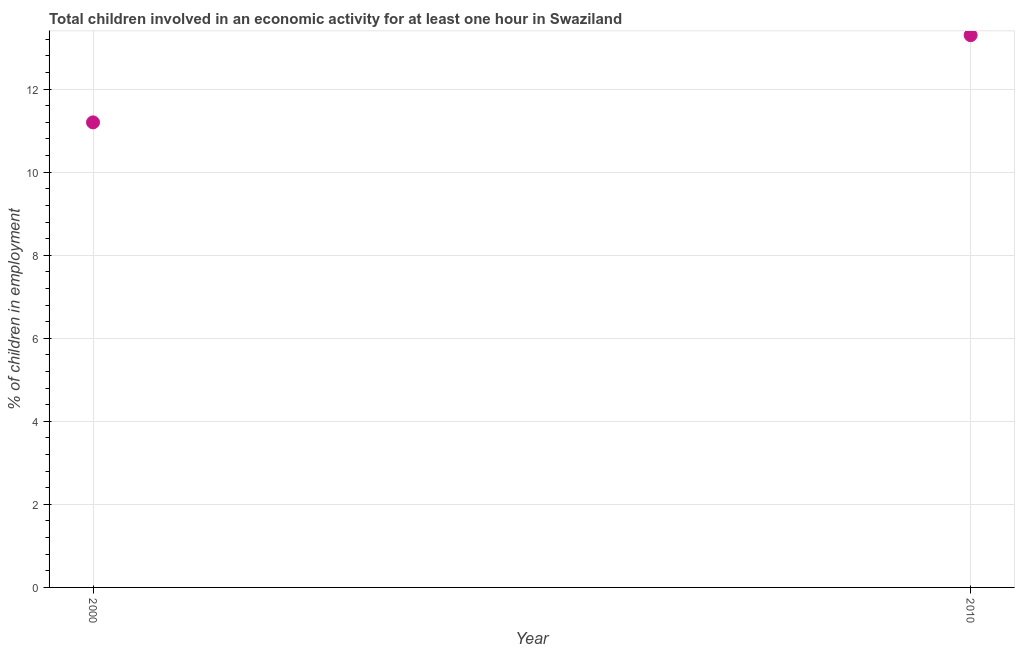Across all years, what is the maximum percentage of children in employment?
Your answer should be compact. 13.3. In which year was the percentage of children in employment maximum?
Provide a short and direct response. 2010. What is the difference between the percentage of children in employment in 2000 and 2010?
Ensure brevity in your answer.  -2.1. What is the average percentage of children in employment per year?
Provide a succinct answer. 12.25. What is the median percentage of children in employment?
Ensure brevity in your answer.  12.25. Do a majority of the years between 2000 and 2010 (inclusive) have percentage of children in employment greater than 3.6 %?
Make the answer very short. Yes. What is the ratio of the percentage of children in employment in 2000 to that in 2010?
Give a very brief answer. 0.84. Is the percentage of children in employment in 2000 less than that in 2010?
Your response must be concise. Yes. Does the percentage of children in employment monotonically increase over the years?
Your answer should be compact. Yes. How many dotlines are there?
Keep it short and to the point. 1. How many years are there in the graph?
Your response must be concise. 2. What is the difference between two consecutive major ticks on the Y-axis?
Give a very brief answer. 2. Does the graph contain any zero values?
Ensure brevity in your answer.  No. Does the graph contain grids?
Your answer should be compact. Yes. What is the title of the graph?
Offer a terse response. Total children involved in an economic activity for at least one hour in Swaziland. What is the label or title of the X-axis?
Provide a succinct answer. Year. What is the label or title of the Y-axis?
Ensure brevity in your answer.  % of children in employment. What is the % of children in employment in 2010?
Your answer should be very brief. 13.3. What is the difference between the % of children in employment in 2000 and 2010?
Provide a succinct answer. -2.1. What is the ratio of the % of children in employment in 2000 to that in 2010?
Ensure brevity in your answer.  0.84. 